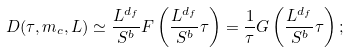Convert formula to latex. <formula><loc_0><loc_0><loc_500><loc_500>D ( \tau , m _ { c } , L ) \simeq \frac { L ^ { d _ { f } } } { S ^ { b } } F \left ( \frac { L ^ { d _ { f } } } { S ^ { b } } \tau \right ) = \frac { 1 } { \tau } G \left ( \frac { L ^ { d _ { f } } } { S ^ { b } } \tau \right ) ;</formula> 